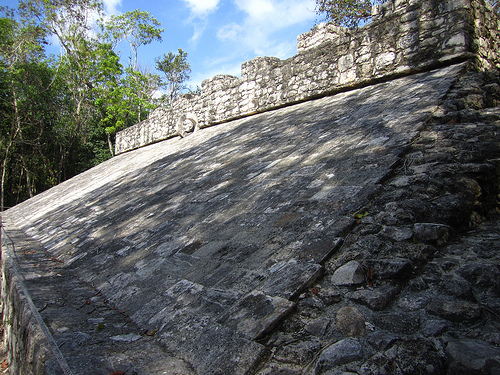<image>
Can you confirm if the roof is on the tree? No. The roof is not positioned on the tree. They may be near each other, but the roof is not supported by or resting on top of the tree. 